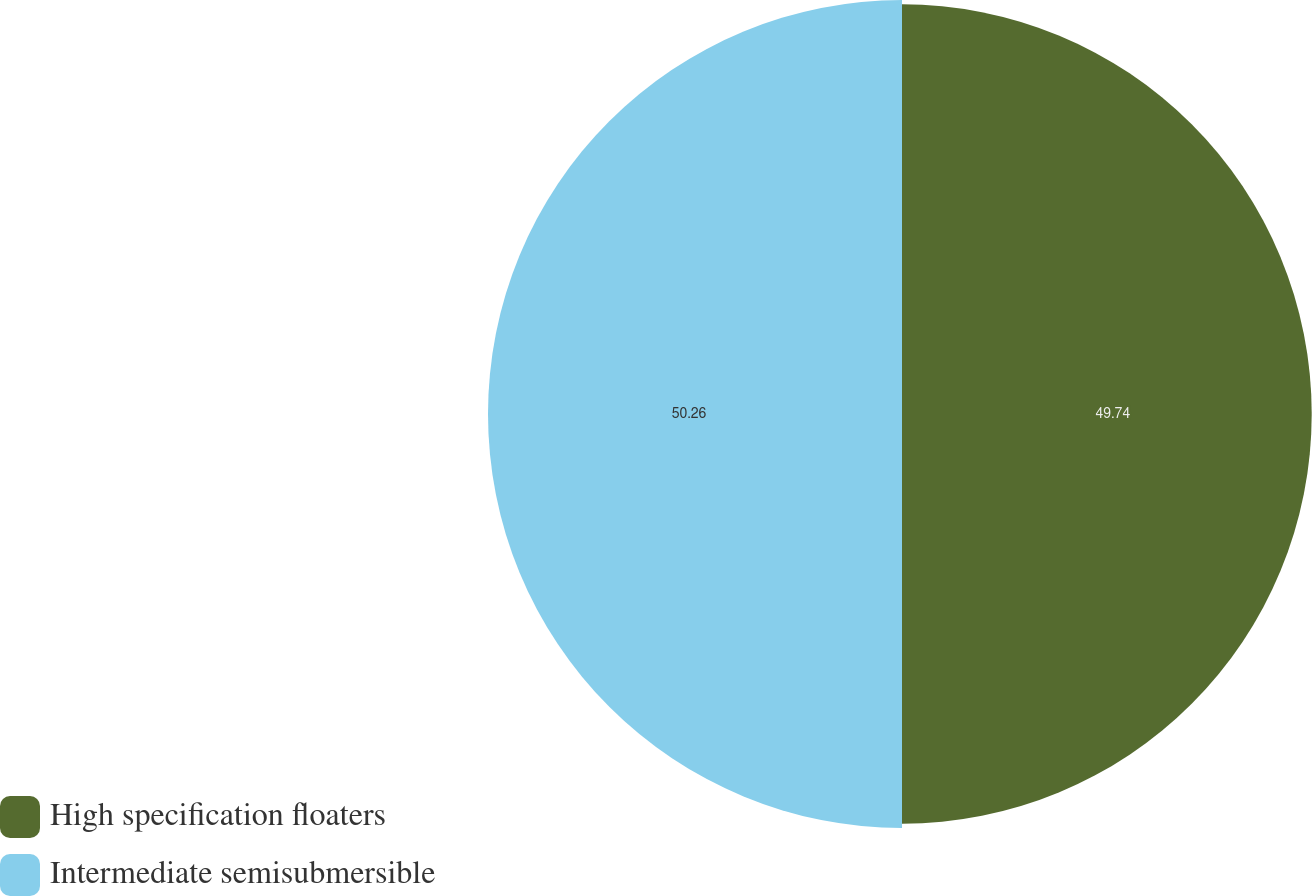Convert chart to OTSL. <chart><loc_0><loc_0><loc_500><loc_500><pie_chart><fcel>High specification floaters<fcel>Intermediate semisubmersible<nl><fcel>49.74%<fcel>50.26%<nl></chart> 